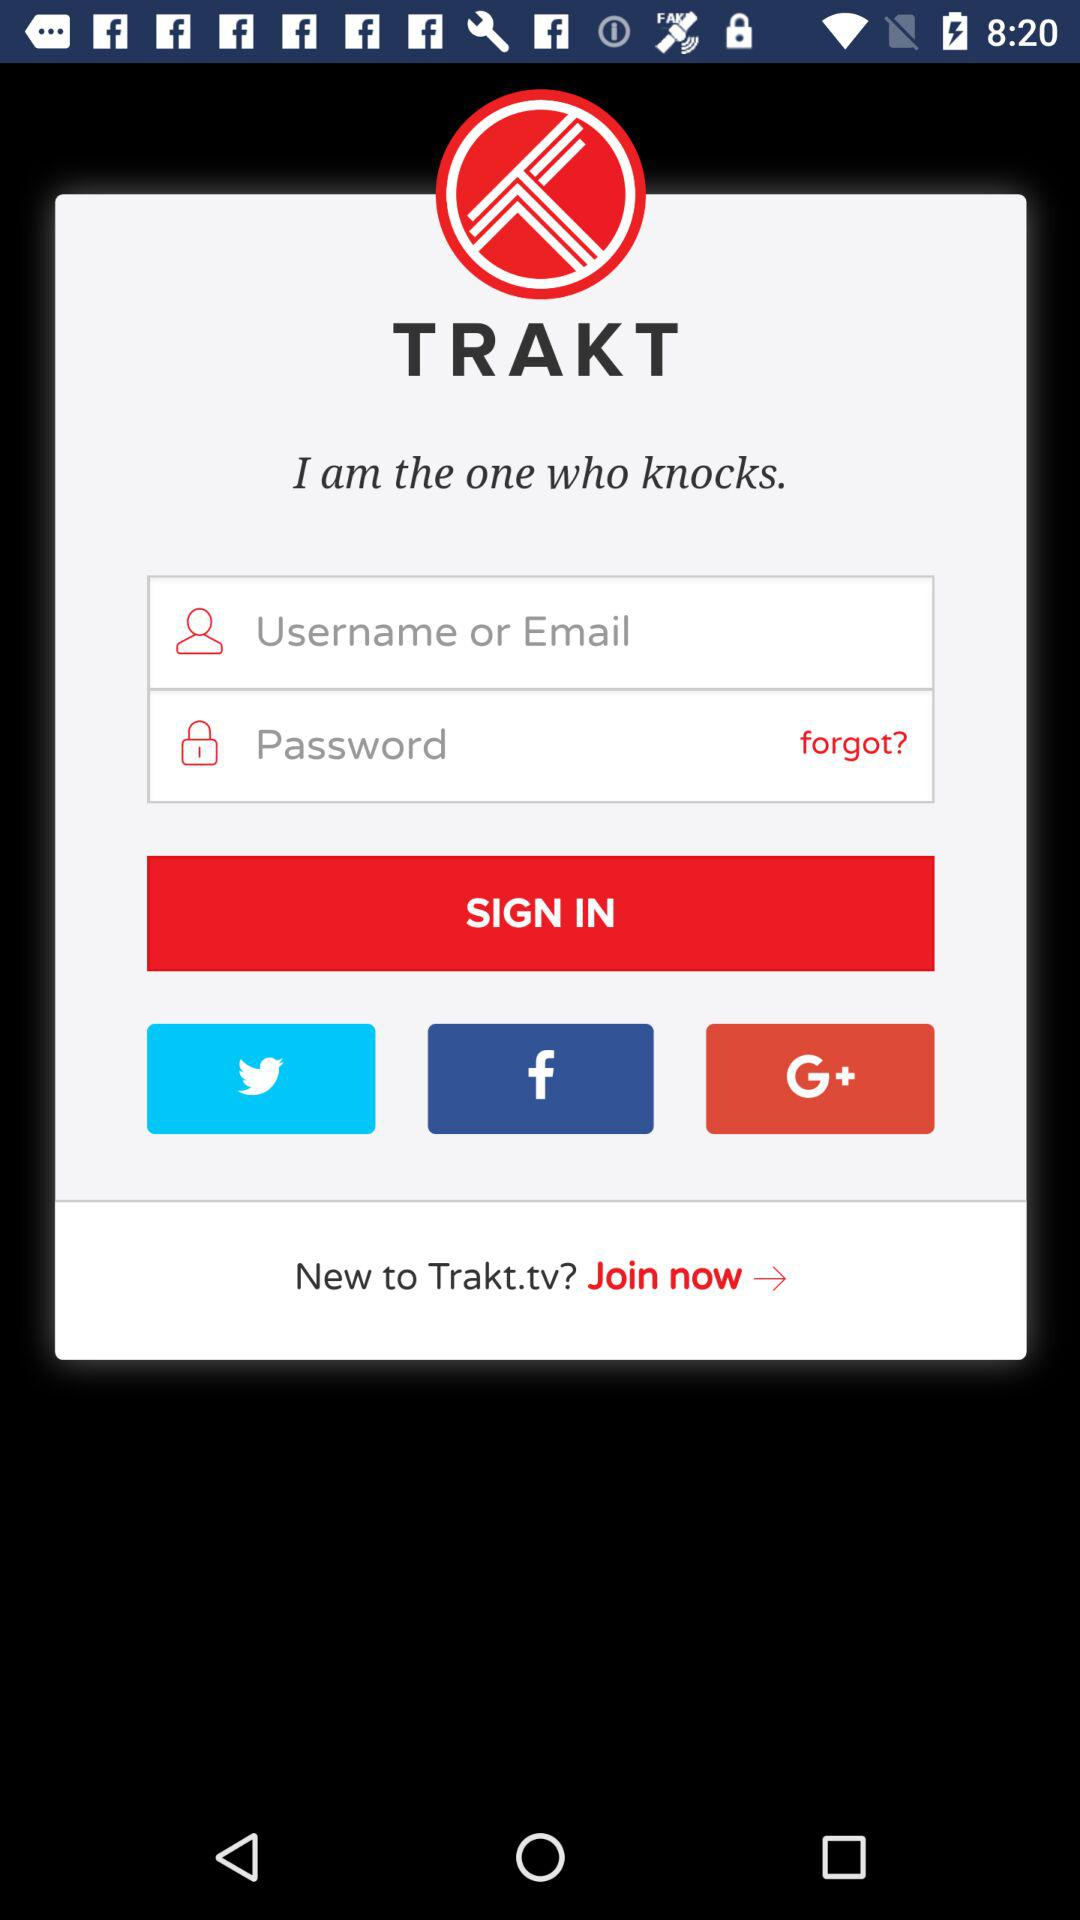How many login fields are there?
Answer the question using a single word or phrase. 2 